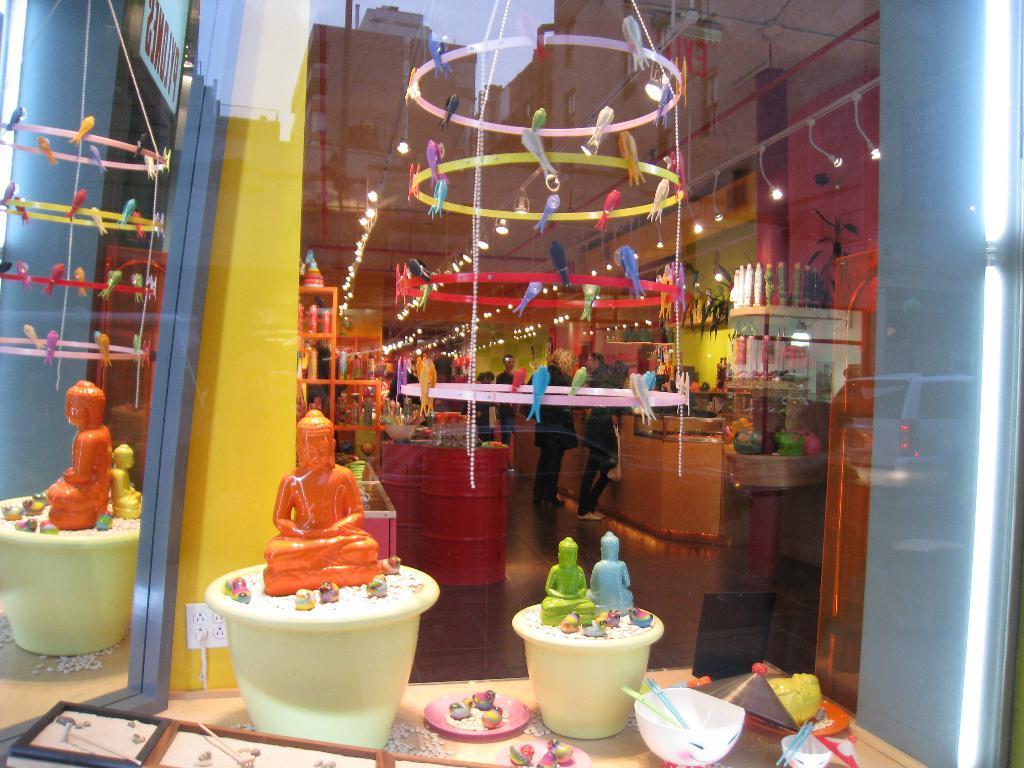How would you summarize this image in a sentence or two? In this picture there are few toys placed on flower pots and there are few people and some other objects in the background. 